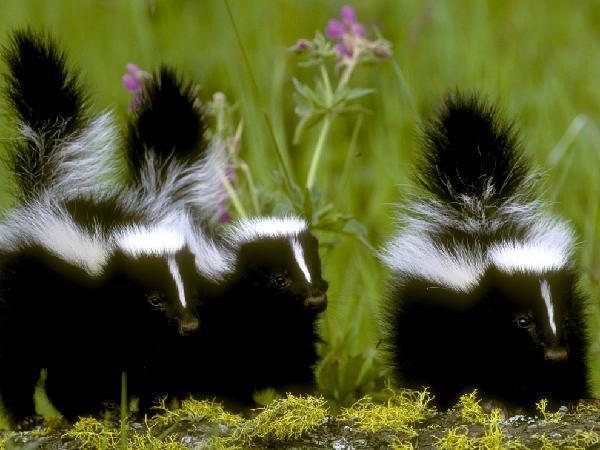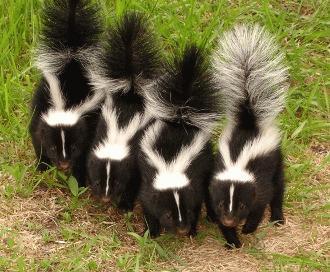The first image is the image on the left, the second image is the image on the right. Assess this claim about the two images: "The skunks in the right image have their tails up.". Correct or not? Answer yes or no. Yes. The first image is the image on the left, the second image is the image on the right. Assess this claim about the two images: "The three skunks on the right are sitting side-by-side in the grass.". Correct or not? Answer yes or no. No. 